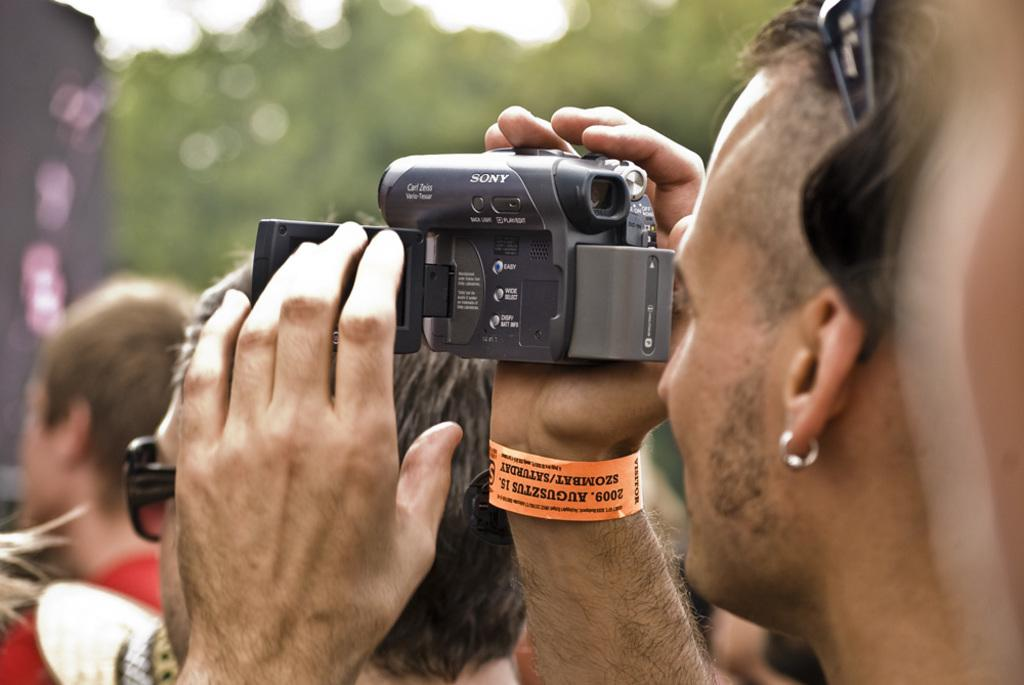What is the main activity of the person in the image? The person in the image is recording a video. Are there any other people present in the image? Yes, there are a few people around the person recording the video. What type of current is flowing through the person's stocking in the image? There is no mention of a person wearing stockings or any current in the image. 